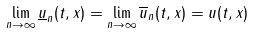<formula> <loc_0><loc_0><loc_500><loc_500>\lim _ { n \to \infty } \underline { u } _ { n } ( t , x ) = \lim _ { n \to \infty } \overline { u } _ { n } ( t , x ) = u ( t , x )</formula> 